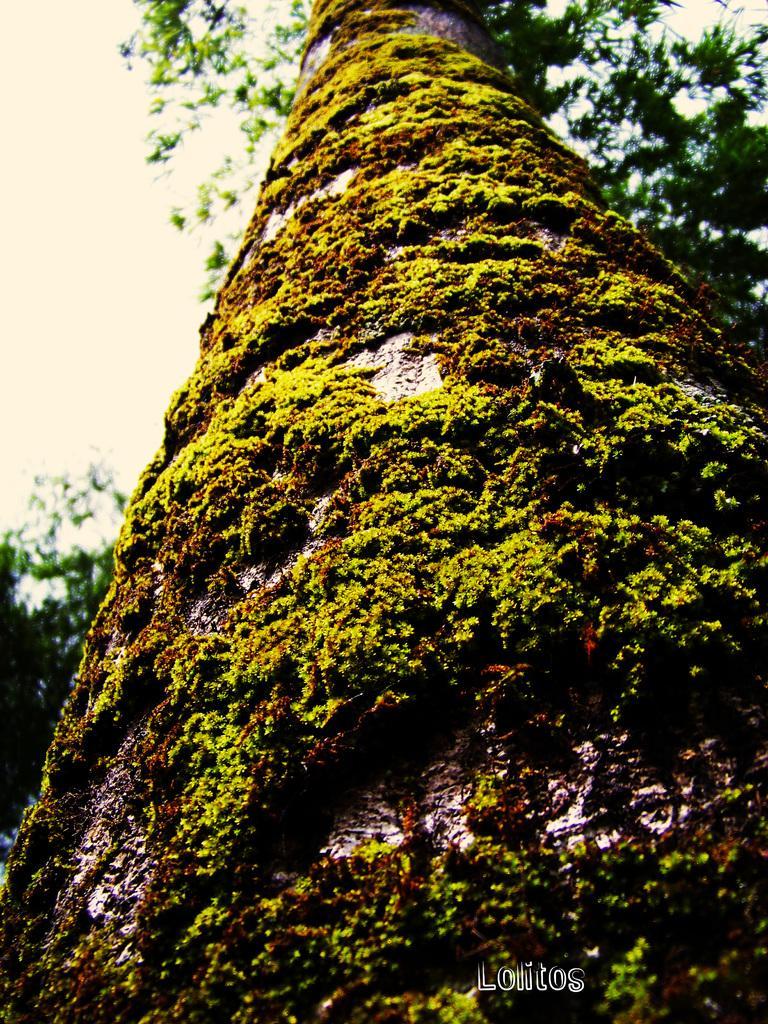In one or two sentences, can you explain what this image depicts? This is a tree. On the tree trunk there are mosses. In the back there is sky. To the down there is a watermark. 